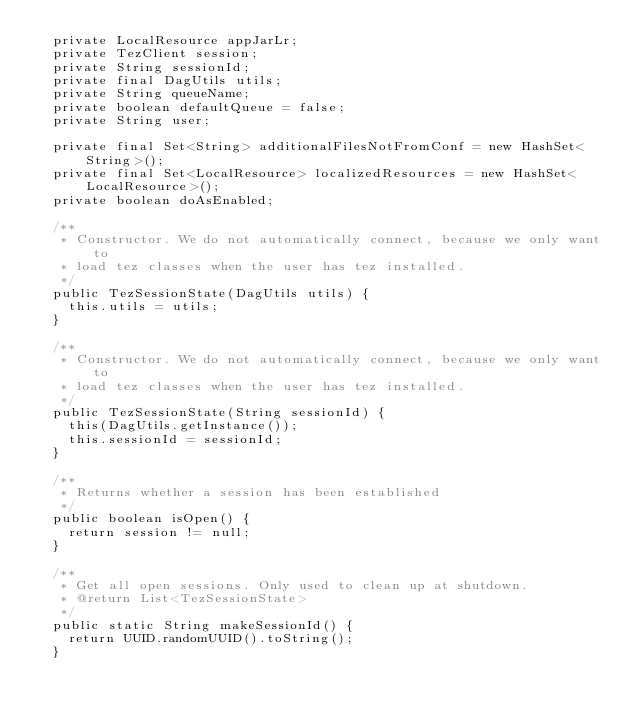<code> <loc_0><loc_0><loc_500><loc_500><_Java_>  private LocalResource appJarLr;
  private TezClient session;
  private String sessionId;
  private final DagUtils utils;
  private String queueName;
  private boolean defaultQueue = false;
  private String user;

  private final Set<String> additionalFilesNotFromConf = new HashSet<String>();
  private final Set<LocalResource> localizedResources = new HashSet<LocalResource>();
  private boolean doAsEnabled;

  /**
   * Constructor. We do not automatically connect, because we only want to
   * load tez classes when the user has tez installed.
   */
  public TezSessionState(DagUtils utils) {
    this.utils = utils;
  }

  /**
   * Constructor. We do not automatically connect, because we only want to
   * load tez classes when the user has tez installed.
   */
  public TezSessionState(String sessionId) {
    this(DagUtils.getInstance());
    this.sessionId = sessionId;
  }

  /**
   * Returns whether a session has been established
   */
  public boolean isOpen() {
    return session != null;
  }

  /**
   * Get all open sessions. Only used to clean up at shutdown.
   * @return List<TezSessionState>
   */
  public static String makeSessionId() {
    return UUID.randomUUID().toString();
  }
</code> 